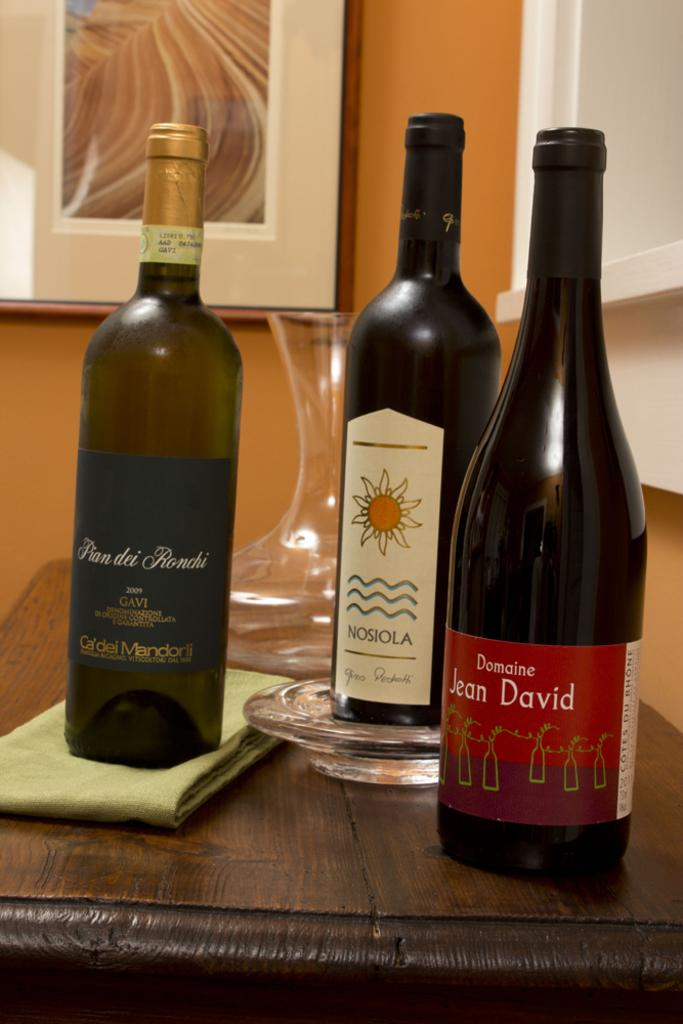<image>
Write a terse but informative summary of the picture. bottles of wine on a table including Nosiola and Domaine Jean David 